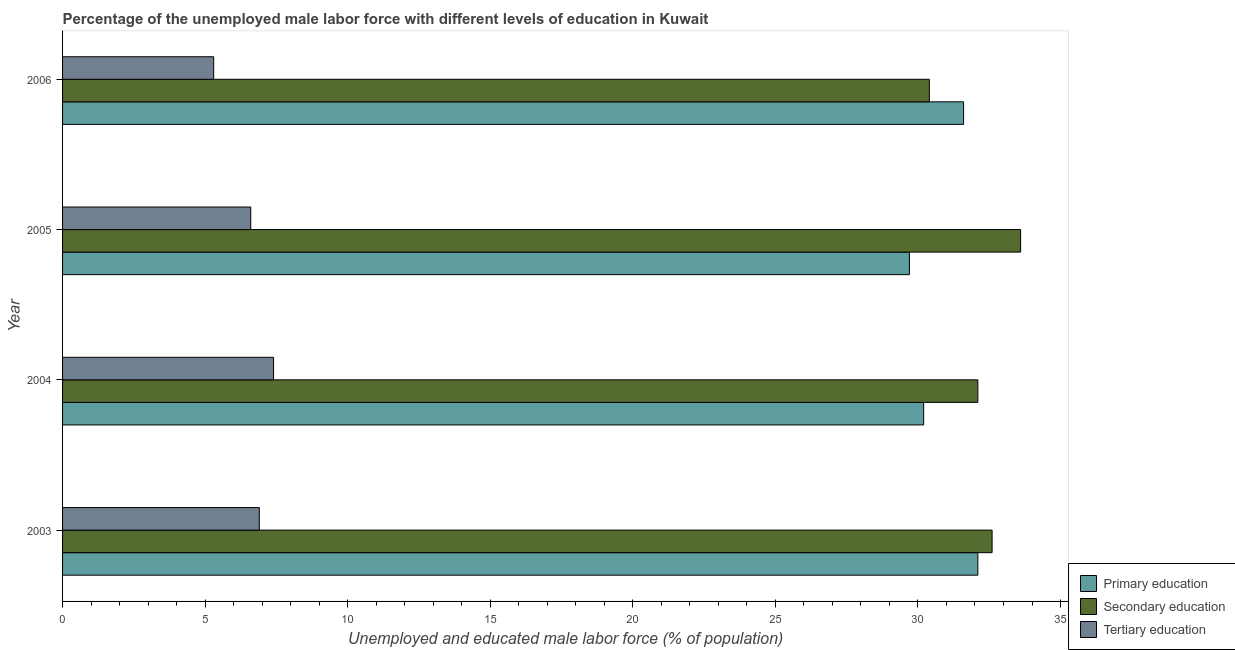Are the number of bars per tick equal to the number of legend labels?
Your response must be concise. Yes. Are the number of bars on each tick of the Y-axis equal?
Provide a short and direct response. Yes. How many bars are there on the 1st tick from the top?
Offer a terse response. 3. How many bars are there on the 2nd tick from the bottom?
Offer a very short reply. 3. What is the label of the 1st group of bars from the top?
Make the answer very short. 2006. In how many cases, is the number of bars for a given year not equal to the number of legend labels?
Offer a very short reply. 0. What is the percentage of male labor force who received primary education in 2006?
Ensure brevity in your answer.  31.6. Across all years, what is the maximum percentage of male labor force who received secondary education?
Give a very brief answer. 33.6. Across all years, what is the minimum percentage of male labor force who received primary education?
Your answer should be compact. 29.7. What is the total percentage of male labor force who received tertiary education in the graph?
Offer a terse response. 26.2. What is the difference between the percentage of male labor force who received primary education in 2004 and the percentage of male labor force who received tertiary education in 2006?
Provide a succinct answer. 24.9. What is the average percentage of male labor force who received secondary education per year?
Provide a short and direct response. 32.17. In the year 2005, what is the difference between the percentage of male labor force who received primary education and percentage of male labor force who received secondary education?
Provide a succinct answer. -3.9. In how many years, is the percentage of male labor force who received tertiary education greater than 19 %?
Offer a terse response. 0. What is the ratio of the percentage of male labor force who received secondary education in 2004 to that in 2005?
Keep it short and to the point. 0.95. Is the difference between the percentage of male labor force who received tertiary education in 2003 and 2006 greater than the difference between the percentage of male labor force who received primary education in 2003 and 2006?
Provide a short and direct response. Yes. What is the difference between the highest and the second highest percentage of male labor force who received primary education?
Give a very brief answer. 0.5. Is the sum of the percentage of male labor force who received primary education in 2004 and 2006 greater than the maximum percentage of male labor force who received secondary education across all years?
Offer a terse response. Yes. What does the 2nd bar from the bottom in 2006 represents?
Keep it short and to the point. Secondary education. Is it the case that in every year, the sum of the percentage of male labor force who received primary education and percentage of male labor force who received secondary education is greater than the percentage of male labor force who received tertiary education?
Offer a terse response. Yes. How many years are there in the graph?
Your response must be concise. 4. What is the title of the graph?
Provide a short and direct response. Percentage of the unemployed male labor force with different levels of education in Kuwait. Does "Natural Gas" appear as one of the legend labels in the graph?
Your answer should be very brief. No. What is the label or title of the X-axis?
Offer a terse response. Unemployed and educated male labor force (% of population). What is the Unemployed and educated male labor force (% of population) of Primary education in 2003?
Make the answer very short. 32.1. What is the Unemployed and educated male labor force (% of population) in Secondary education in 2003?
Provide a short and direct response. 32.6. What is the Unemployed and educated male labor force (% of population) of Tertiary education in 2003?
Give a very brief answer. 6.9. What is the Unemployed and educated male labor force (% of population) in Primary education in 2004?
Provide a short and direct response. 30.2. What is the Unemployed and educated male labor force (% of population) in Secondary education in 2004?
Your response must be concise. 32.1. What is the Unemployed and educated male labor force (% of population) in Tertiary education in 2004?
Offer a terse response. 7.4. What is the Unemployed and educated male labor force (% of population) of Primary education in 2005?
Give a very brief answer. 29.7. What is the Unemployed and educated male labor force (% of population) of Secondary education in 2005?
Your answer should be very brief. 33.6. What is the Unemployed and educated male labor force (% of population) of Tertiary education in 2005?
Keep it short and to the point. 6.6. What is the Unemployed and educated male labor force (% of population) of Primary education in 2006?
Give a very brief answer. 31.6. What is the Unemployed and educated male labor force (% of population) of Secondary education in 2006?
Make the answer very short. 30.4. What is the Unemployed and educated male labor force (% of population) of Tertiary education in 2006?
Your answer should be compact. 5.3. Across all years, what is the maximum Unemployed and educated male labor force (% of population) in Primary education?
Offer a very short reply. 32.1. Across all years, what is the maximum Unemployed and educated male labor force (% of population) of Secondary education?
Provide a succinct answer. 33.6. Across all years, what is the maximum Unemployed and educated male labor force (% of population) in Tertiary education?
Make the answer very short. 7.4. Across all years, what is the minimum Unemployed and educated male labor force (% of population) in Primary education?
Your response must be concise. 29.7. Across all years, what is the minimum Unemployed and educated male labor force (% of population) in Secondary education?
Make the answer very short. 30.4. Across all years, what is the minimum Unemployed and educated male labor force (% of population) of Tertiary education?
Keep it short and to the point. 5.3. What is the total Unemployed and educated male labor force (% of population) in Primary education in the graph?
Your response must be concise. 123.6. What is the total Unemployed and educated male labor force (% of population) in Secondary education in the graph?
Offer a terse response. 128.7. What is the total Unemployed and educated male labor force (% of population) of Tertiary education in the graph?
Your answer should be very brief. 26.2. What is the difference between the Unemployed and educated male labor force (% of population) in Secondary education in 2003 and that in 2005?
Your answer should be compact. -1. What is the difference between the Unemployed and educated male labor force (% of population) of Tertiary education in 2003 and that in 2005?
Your answer should be compact. 0.3. What is the difference between the Unemployed and educated male labor force (% of population) of Primary education in 2004 and that in 2005?
Your answer should be very brief. 0.5. What is the difference between the Unemployed and educated male labor force (% of population) of Secondary education in 2004 and that in 2005?
Give a very brief answer. -1.5. What is the difference between the Unemployed and educated male labor force (% of population) of Tertiary education in 2004 and that in 2005?
Your response must be concise. 0.8. What is the difference between the Unemployed and educated male labor force (% of population) of Tertiary education in 2004 and that in 2006?
Provide a short and direct response. 2.1. What is the difference between the Unemployed and educated male labor force (% of population) in Primary education in 2005 and that in 2006?
Give a very brief answer. -1.9. What is the difference between the Unemployed and educated male labor force (% of population) of Tertiary education in 2005 and that in 2006?
Provide a succinct answer. 1.3. What is the difference between the Unemployed and educated male labor force (% of population) in Primary education in 2003 and the Unemployed and educated male labor force (% of population) in Secondary education in 2004?
Offer a very short reply. 0. What is the difference between the Unemployed and educated male labor force (% of population) of Primary education in 2003 and the Unemployed and educated male labor force (% of population) of Tertiary education in 2004?
Provide a short and direct response. 24.7. What is the difference between the Unemployed and educated male labor force (% of population) of Secondary education in 2003 and the Unemployed and educated male labor force (% of population) of Tertiary education in 2004?
Offer a very short reply. 25.2. What is the difference between the Unemployed and educated male labor force (% of population) in Primary education in 2003 and the Unemployed and educated male labor force (% of population) in Secondary education in 2005?
Give a very brief answer. -1.5. What is the difference between the Unemployed and educated male labor force (% of population) of Primary education in 2003 and the Unemployed and educated male labor force (% of population) of Tertiary education in 2006?
Offer a very short reply. 26.8. What is the difference between the Unemployed and educated male labor force (% of population) in Secondary education in 2003 and the Unemployed and educated male labor force (% of population) in Tertiary education in 2006?
Give a very brief answer. 27.3. What is the difference between the Unemployed and educated male labor force (% of population) in Primary education in 2004 and the Unemployed and educated male labor force (% of population) in Tertiary education in 2005?
Provide a succinct answer. 23.6. What is the difference between the Unemployed and educated male labor force (% of population) of Primary education in 2004 and the Unemployed and educated male labor force (% of population) of Tertiary education in 2006?
Your answer should be very brief. 24.9. What is the difference between the Unemployed and educated male labor force (% of population) of Secondary education in 2004 and the Unemployed and educated male labor force (% of population) of Tertiary education in 2006?
Provide a short and direct response. 26.8. What is the difference between the Unemployed and educated male labor force (% of population) in Primary education in 2005 and the Unemployed and educated male labor force (% of population) in Tertiary education in 2006?
Keep it short and to the point. 24.4. What is the difference between the Unemployed and educated male labor force (% of population) in Secondary education in 2005 and the Unemployed and educated male labor force (% of population) in Tertiary education in 2006?
Keep it short and to the point. 28.3. What is the average Unemployed and educated male labor force (% of population) of Primary education per year?
Make the answer very short. 30.9. What is the average Unemployed and educated male labor force (% of population) in Secondary education per year?
Provide a short and direct response. 32.17. What is the average Unemployed and educated male labor force (% of population) in Tertiary education per year?
Make the answer very short. 6.55. In the year 2003, what is the difference between the Unemployed and educated male labor force (% of population) of Primary education and Unemployed and educated male labor force (% of population) of Tertiary education?
Give a very brief answer. 25.2. In the year 2003, what is the difference between the Unemployed and educated male labor force (% of population) in Secondary education and Unemployed and educated male labor force (% of population) in Tertiary education?
Keep it short and to the point. 25.7. In the year 2004, what is the difference between the Unemployed and educated male labor force (% of population) of Primary education and Unemployed and educated male labor force (% of population) of Secondary education?
Ensure brevity in your answer.  -1.9. In the year 2004, what is the difference between the Unemployed and educated male labor force (% of population) of Primary education and Unemployed and educated male labor force (% of population) of Tertiary education?
Give a very brief answer. 22.8. In the year 2004, what is the difference between the Unemployed and educated male labor force (% of population) of Secondary education and Unemployed and educated male labor force (% of population) of Tertiary education?
Your response must be concise. 24.7. In the year 2005, what is the difference between the Unemployed and educated male labor force (% of population) in Primary education and Unemployed and educated male labor force (% of population) in Secondary education?
Provide a succinct answer. -3.9. In the year 2005, what is the difference between the Unemployed and educated male labor force (% of population) of Primary education and Unemployed and educated male labor force (% of population) of Tertiary education?
Make the answer very short. 23.1. In the year 2006, what is the difference between the Unemployed and educated male labor force (% of population) in Primary education and Unemployed and educated male labor force (% of population) in Secondary education?
Ensure brevity in your answer.  1.2. In the year 2006, what is the difference between the Unemployed and educated male labor force (% of population) of Primary education and Unemployed and educated male labor force (% of population) of Tertiary education?
Your answer should be very brief. 26.3. In the year 2006, what is the difference between the Unemployed and educated male labor force (% of population) of Secondary education and Unemployed and educated male labor force (% of population) of Tertiary education?
Ensure brevity in your answer.  25.1. What is the ratio of the Unemployed and educated male labor force (% of population) in Primary education in 2003 to that in 2004?
Your response must be concise. 1.06. What is the ratio of the Unemployed and educated male labor force (% of population) of Secondary education in 2003 to that in 2004?
Make the answer very short. 1.02. What is the ratio of the Unemployed and educated male labor force (% of population) in Tertiary education in 2003 to that in 2004?
Your answer should be compact. 0.93. What is the ratio of the Unemployed and educated male labor force (% of population) of Primary education in 2003 to that in 2005?
Offer a terse response. 1.08. What is the ratio of the Unemployed and educated male labor force (% of population) of Secondary education in 2003 to that in 2005?
Your response must be concise. 0.97. What is the ratio of the Unemployed and educated male labor force (% of population) of Tertiary education in 2003 to that in 2005?
Your answer should be compact. 1.05. What is the ratio of the Unemployed and educated male labor force (% of population) of Primary education in 2003 to that in 2006?
Keep it short and to the point. 1.02. What is the ratio of the Unemployed and educated male labor force (% of population) of Secondary education in 2003 to that in 2006?
Your answer should be very brief. 1.07. What is the ratio of the Unemployed and educated male labor force (% of population) in Tertiary education in 2003 to that in 2006?
Offer a very short reply. 1.3. What is the ratio of the Unemployed and educated male labor force (% of population) of Primary education in 2004 to that in 2005?
Your answer should be compact. 1.02. What is the ratio of the Unemployed and educated male labor force (% of population) of Secondary education in 2004 to that in 2005?
Your response must be concise. 0.96. What is the ratio of the Unemployed and educated male labor force (% of population) of Tertiary education in 2004 to that in 2005?
Keep it short and to the point. 1.12. What is the ratio of the Unemployed and educated male labor force (% of population) of Primary education in 2004 to that in 2006?
Give a very brief answer. 0.96. What is the ratio of the Unemployed and educated male labor force (% of population) in Secondary education in 2004 to that in 2006?
Ensure brevity in your answer.  1.06. What is the ratio of the Unemployed and educated male labor force (% of population) of Tertiary education in 2004 to that in 2006?
Your answer should be very brief. 1.4. What is the ratio of the Unemployed and educated male labor force (% of population) in Primary education in 2005 to that in 2006?
Make the answer very short. 0.94. What is the ratio of the Unemployed and educated male labor force (% of population) of Secondary education in 2005 to that in 2006?
Your response must be concise. 1.11. What is the ratio of the Unemployed and educated male labor force (% of population) of Tertiary education in 2005 to that in 2006?
Your answer should be compact. 1.25. What is the difference between the highest and the second highest Unemployed and educated male labor force (% of population) in Primary education?
Offer a very short reply. 0.5. What is the difference between the highest and the second highest Unemployed and educated male labor force (% of population) of Tertiary education?
Offer a very short reply. 0.5. What is the difference between the highest and the lowest Unemployed and educated male labor force (% of population) in Secondary education?
Keep it short and to the point. 3.2. What is the difference between the highest and the lowest Unemployed and educated male labor force (% of population) of Tertiary education?
Make the answer very short. 2.1. 